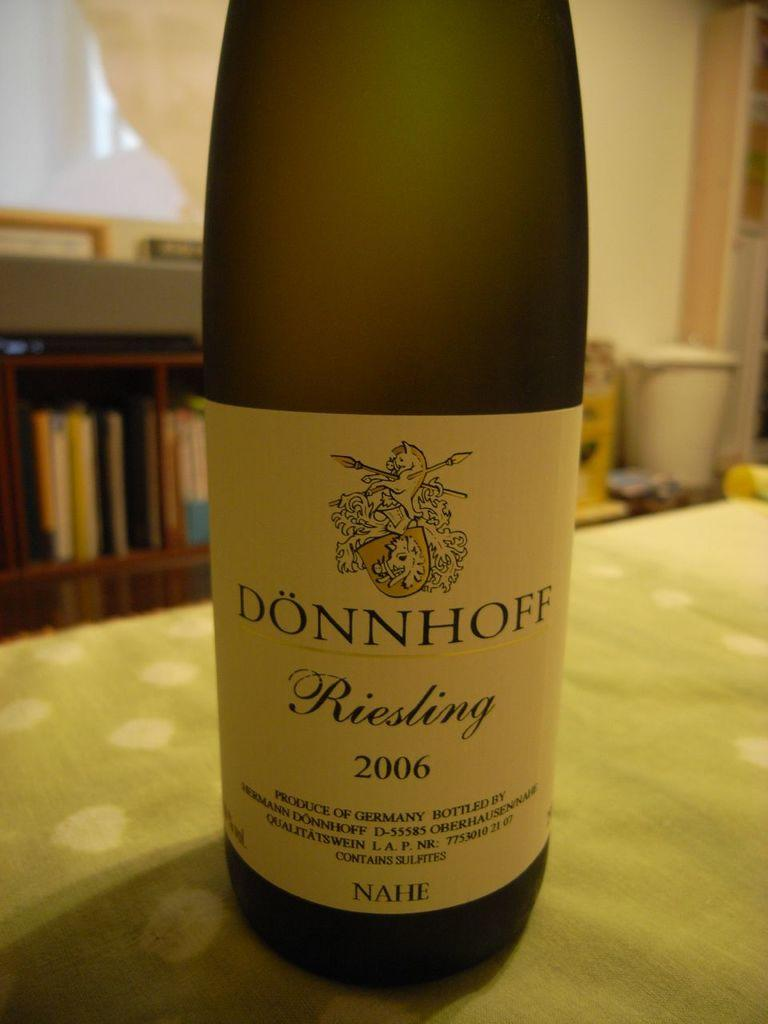<image>
Share a concise interpretation of the image provided. A bottle of Donnhoff Riesling from 2006 is on the table. 